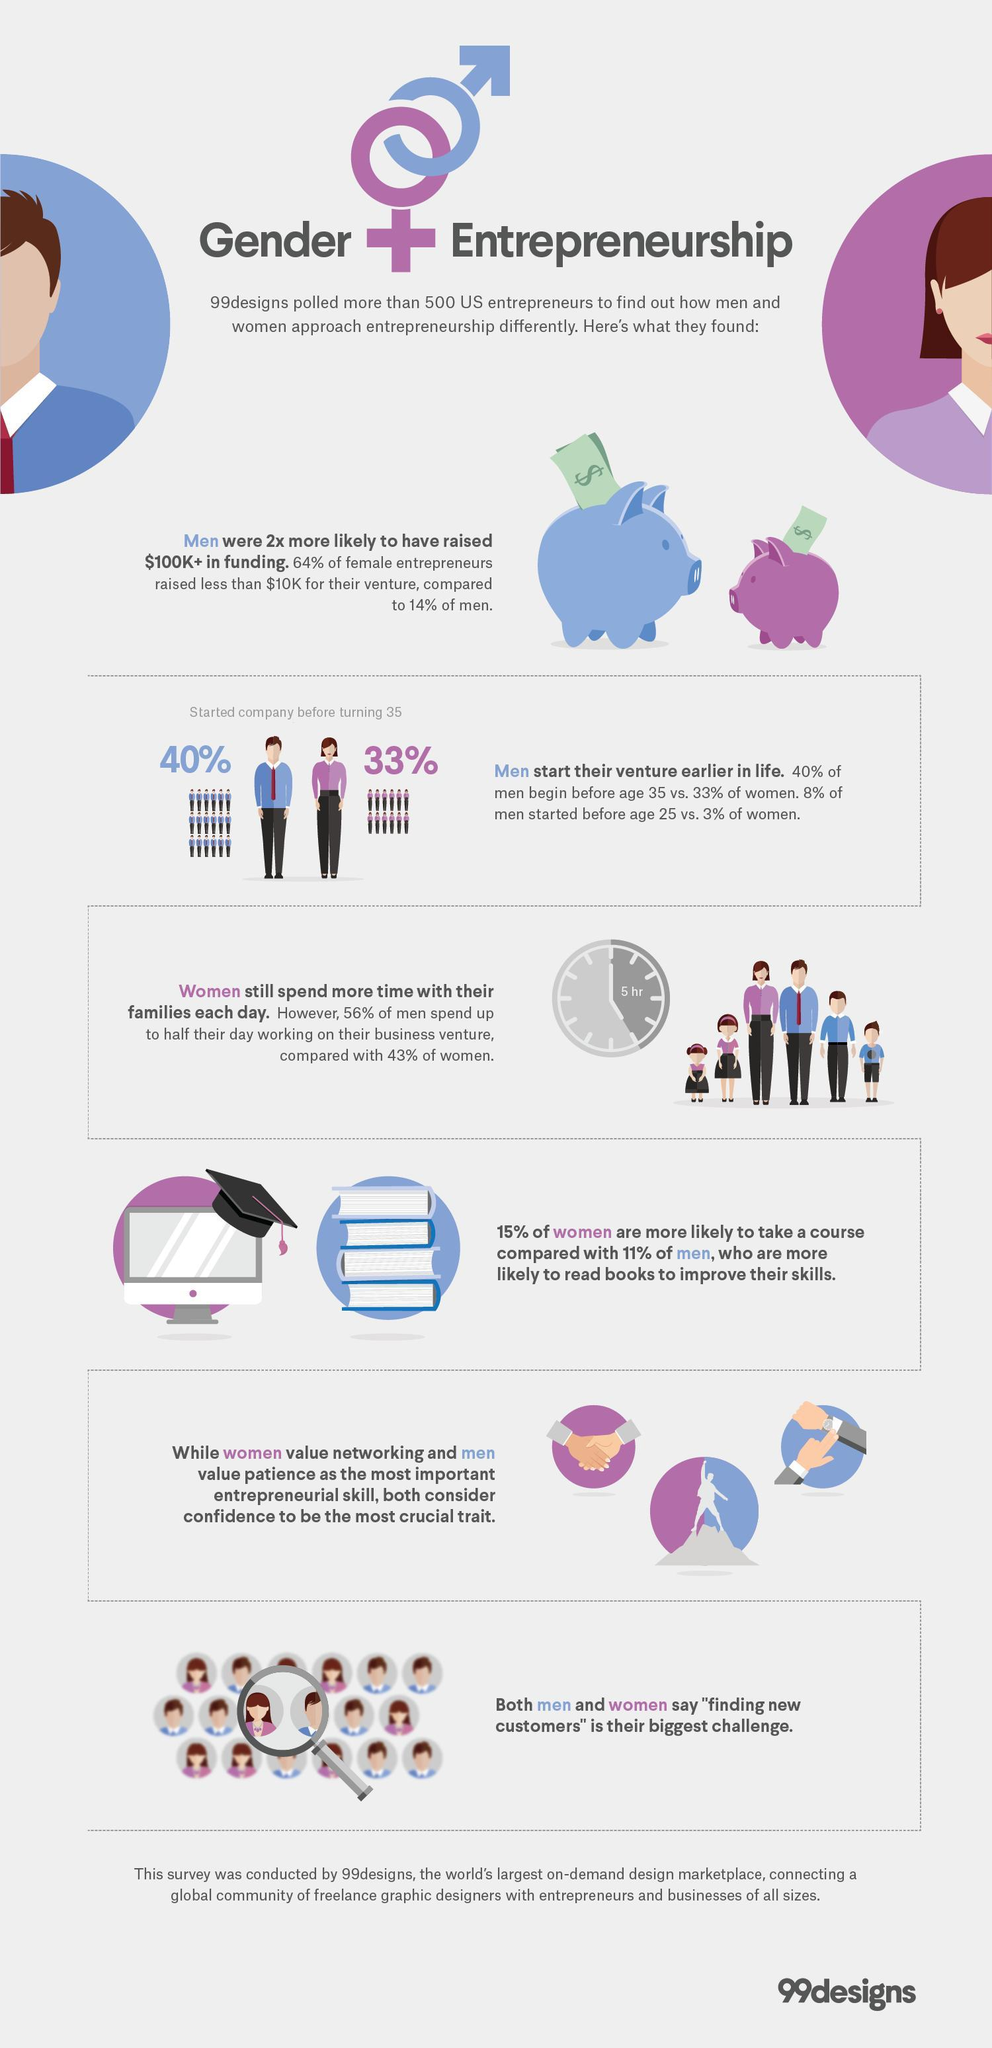What percentage of U.S. entrepreneurs who started a company before 35 were men?
Answer the question with a short phrase. 40% What percentage of women in the U.S. spend half of their day working on their business venture? 43% What percentage of U.S. entrepreneurs who started a company before 35 were women? 33% 